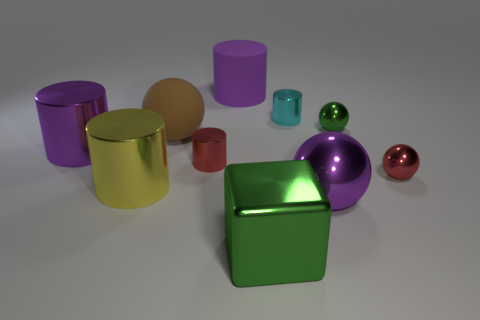Is the number of big brown matte things that are to the right of the brown object less than the number of tiny metal spheres that are behind the small green sphere?
Your answer should be compact. No. Is the number of tiny shiny spheres to the left of the matte ball greater than the number of purple metal things that are to the right of the yellow cylinder?
Your answer should be compact. No. Do the red cylinder and the red metal sphere have the same size?
Provide a short and direct response. Yes. There is a rubber cylinder; are there any large green blocks to the left of it?
Give a very brief answer. No. What is the material of the sphere that is the same color as the metal block?
Give a very brief answer. Metal. Is the material of the green thing that is behind the large metallic block the same as the brown sphere?
Your response must be concise. No. There is a matte thing in front of the matte thing that is on the right side of the large brown object; are there any large metal things that are behind it?
Offer a very short reply. No. What number of blocks are either matte objects or purple objects?
Provide a short and direct response. 0. What is the big brown object left of the small green metal thing made of?
Provide a short and direct response. Rubber. There is a shiny cylinder that is the same color as the large matte cylinder; what size is it?
Your answer should be very brief. Large. 